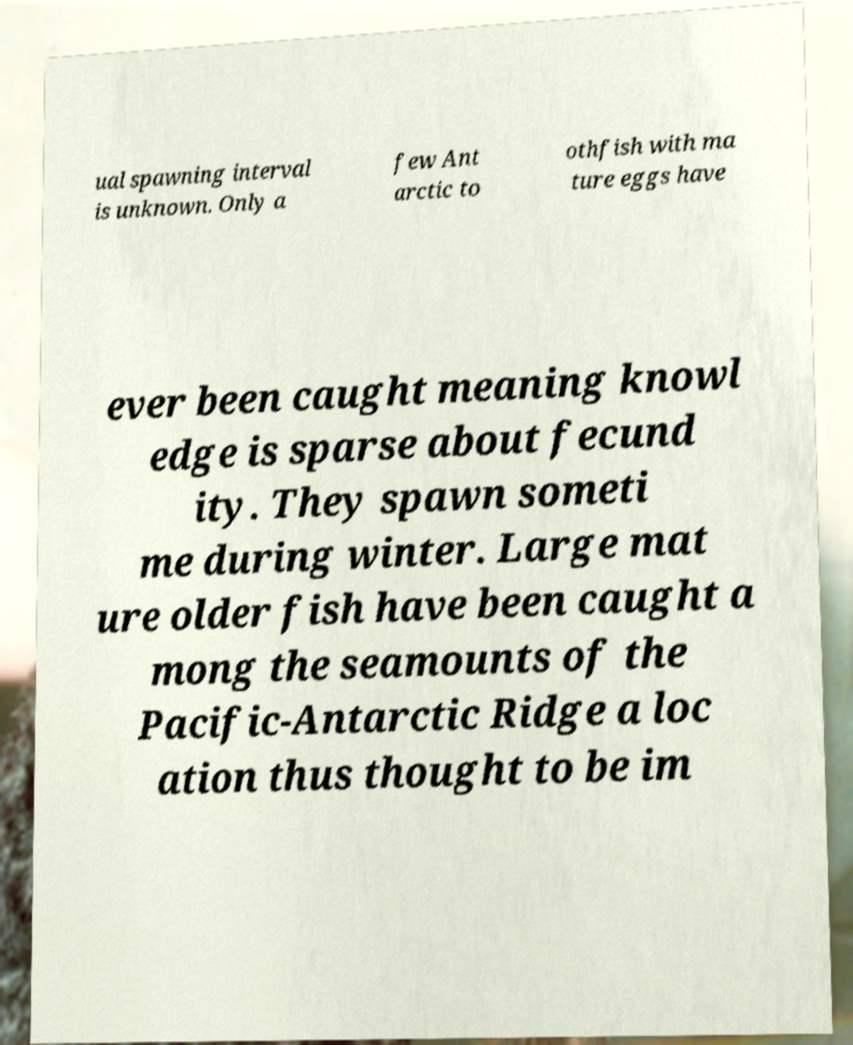Could you extract and type out the text from this image? ual spawning interval is unknown. Only a few Ant arctic to othfish with ma ture eggs have ever been caught meaning knowl edge is sparse about fecund ity. They spawn someti me during winter. Large mat ure older fish have been caught a mong the seamounts of the Pacific-Antarctic Ridge a loc ation thus thought to be im 